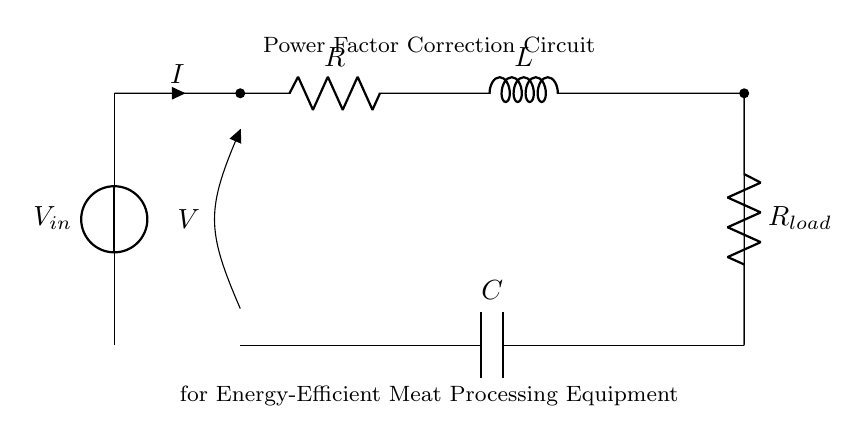What is the type of circuit shown? This is a Power Factor Correction Circuit. It is specifically designed to enhance the efficiency of power delivery in electrical systems, particularly for inductive loads common in meat processing equipment.
Answer: Power Factor Correction Circuit What component is primarily used to counteract inductance? The capacitor is the component designed to counteract the effects of inductance in the circuit, providing a leading current to improve the overall power factor.
Answer: Capacitor What is the role of the resistor in the circuit? The resistor helps in dissipating energy and stabilizing the circuit but can also represent losses in an ideal scenario. It is used to manage voltage and current levels within the circuit.
Answer: Resistor Which component stores energy for a longer duration? The inductor stores energy in its magnetic field when current flows through it, and this stored energy is released back into the circuit when the current decreases.
Answer: Inductor What is the connection type between the resistor and inductor? The resistor and inductor are connected in series, allowing the same current to flow through both components while affecting the voltage across each independently.
Answer: Series What effect does adding a capacitor have on the overall power factor? Adding a capacitor reduces the total phase difference between the voltage and current waveforms, thereby improving the power factor and leading to a more efficient operation of the equipment.
Answer: Improves power factor What is the load represented as in the circuit? The load is represented as another resistor, which represents the power-consuming element of the circuit, reflecting the actual load based on the equipment being powered.
Answer: Load Resistor 